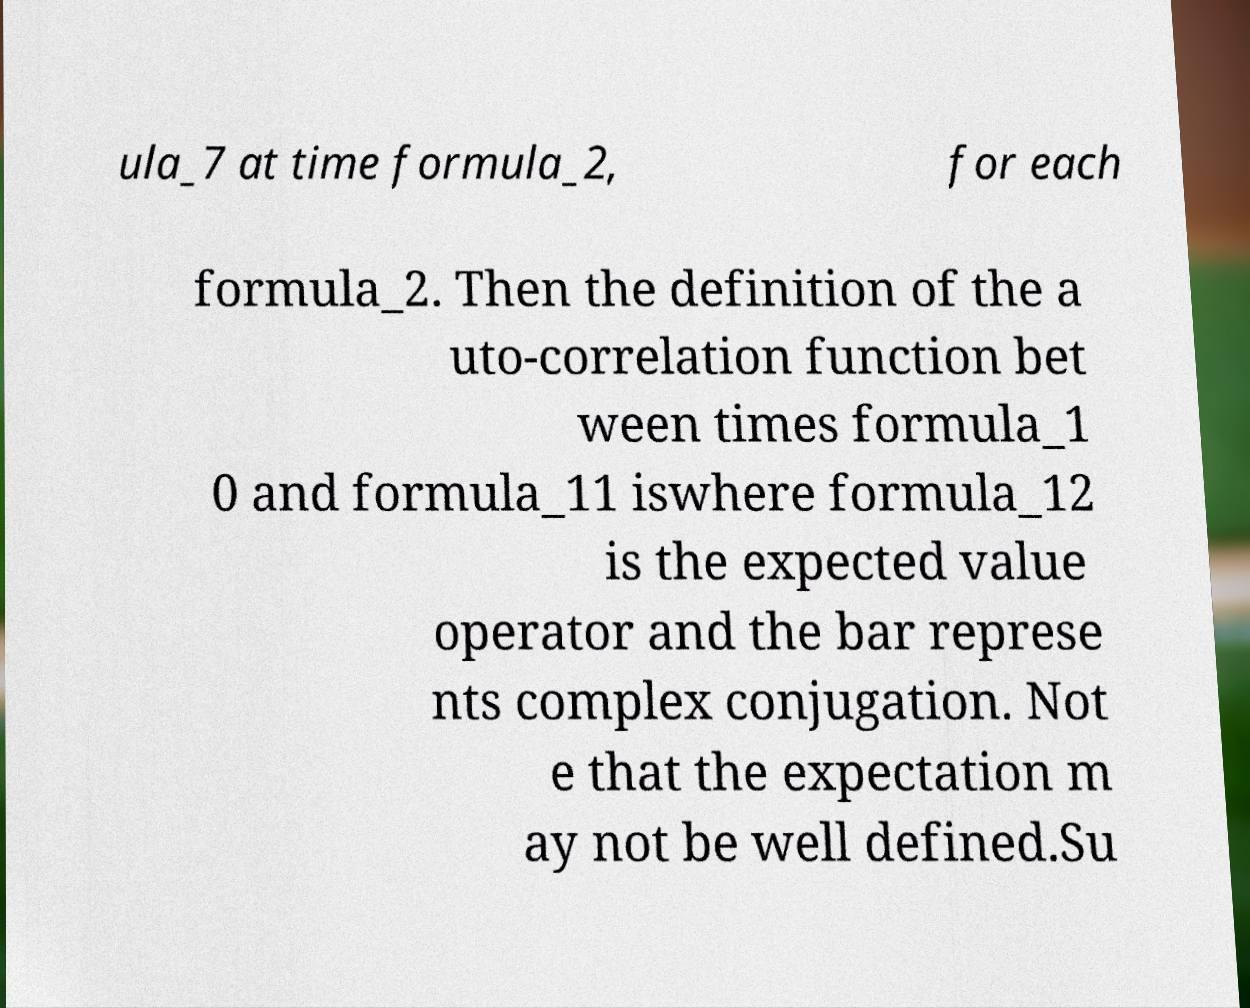For documentation purposes, I need the text within this image transcribed. Could you provide that? ula_7 at time formula_2, for each formula_2. Then the definition of the a uto-correlation function bet ween times formula_1 0 and formula_11 iswhere formula_12 is the expected value operator and the bar represe nts complex conjugation. Not e that the expectation m ay not be well defined.Su 